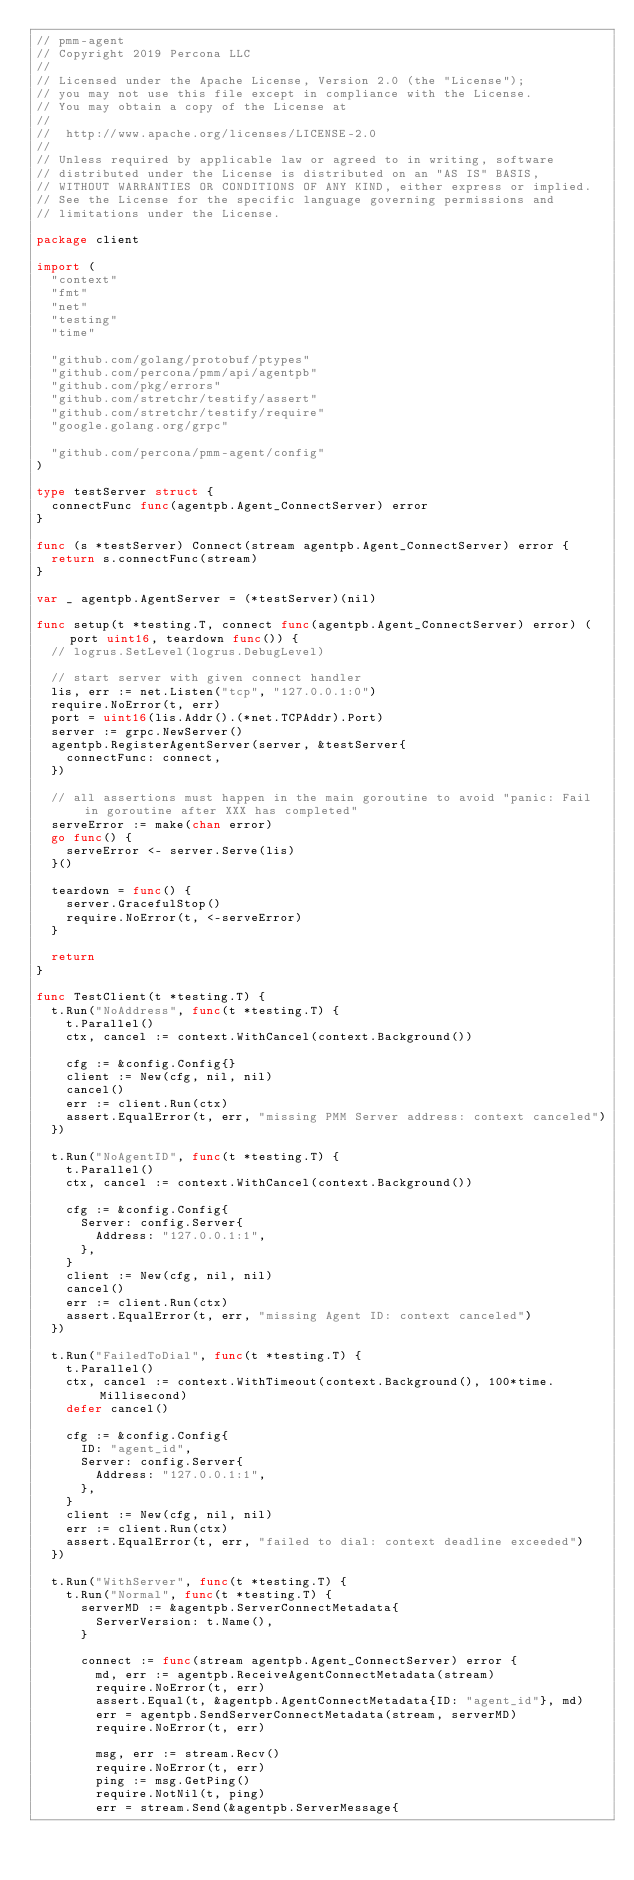Convert code to text. <code><loc_0><loc_0><loc_500><loc_500><_Go_>// pmm-agent
// Copyright 2019 Percona LLC
//
// Licensed under the Apache License, Version 2.0 (the "License");
// you may not use this file except in compliance with the License.
// You may obtain a copy of the License at
//
//  http://www.apache.org/licenses/LICENSE-2.0
//
// Unless required by applicable law or agreed to in writing, software
// distributed under the License is distributed on an "AS IS" BASIS,
// WITHOUT WARRANTIES OR CONDITIONS OF ANY KIND, either express or implied.
// See the License for the specific language governing permissions and
// limitations under the License.

package client

import (
	"context"
	"fmt"
	"net"
	"testing"
	"time"

	"github.com/golang/protobuf/ptypes"
	"github.com/percona/pmm/api/agentpb"
	"github.com/pkg/errors"
	"github.com/stretchr/testify/assert"
	"github.com/stretchr/testify/require"
	"google.golang.org/grpc"

	"github.com/percona/pmm-agent/config"
)

type testServer struct {
	connectFunc func(agentpb.Agent_ConnectServer) error
}

func (s *testServer) Connect(stream agentpb.Agent_ConnectServer) error {
	return s.connectFunc(stream)
}

var _ agentpb.AgentServer = (*testServer)(nil)

func setup(t *testing.T, connect func(agentpb.Agent_ConnectServer) error) (port uint16, teardown func()) {
	// logrus.SetLevel(logrus.DebugLevel)

	// start server with given connect handler
	lis, err := net.Listen("tcp", "127.0.0.1:0")
	require.NoError(t, err)
	port = uint16(lis.Addr().(*net.TCPAddr).Port)
	server := grpc.NewServer()
	agentpb.RegisterAgentServer(server, &testServer{
		connectFunc: connect,
	})

	// all assertions must happen in the main goroutine to avoid "panic: Fail in goroutine after XXX has completed"
	serveError := make(chan error)
	go func() {
		serveError <- server.Serve(lis)
	}()

	teardown = func() {
		server.GracefulStop()
		require.NoError(t, <-serveError)
	}

	return
}

func TestClient(t *testing.T) {
	t.Run("NoAddress", func(t *testing.T) {
		t.Parallel()
		ctx, cancel := context.WithCancel(context.Background())

		cfg := &config.Config{}
		client := New(cfg, nil, nil)
		cancel()
		err := client.Run(ctx)
		assert.EqualError(t, err, "missing PMM Server address: context canceled")
	})

	t.Run("NoAgentID", func(t *testing.T) {
		t.Parallel()
		ctx, cancel := context.WithCancel(context.Background())

		cfg := &config.Config{
			Server: config.Server{
				Address: "127.0.0.1:1",
			},
		}
		client := New(cfg, nil, nil)
		cancel()
		err := client.Run(ctx)
		assert.EqualError(t, err, "missing Agent ID: context canceled")
	})

	t.Run("FailedToDial", func(t *testing.T) {
		t.Parallel()
		ctx, cancel := context.WithTimeout(context.Background(), 100*time.Millisecond)
		defer cancel()

		cfg := &config.Config{
			ID: "agent_id",
			Server: config.Server{
				Address: "127.0.0.1:1",
			},
		}
		client := New(cfg, nil, nil)
		err := client.Run(ctx)
		assert.EqualError(t, err, "failed to dial: context deadline exceeded")
	})

	t.Run("WithServer", func(t *testing.T) {
		t.Run("Normal", func(t *testing.T) {
			serverMD := &agentpb.ServerConnectMetadata{
				ServerVersion: t.Name(),
			}

			connect := func(stream agentpb.Agent_ConnectServer) error {
				md, err := agentpb.ReceiveAgentConnectMetadata(stream)
				require.NoError(t, err)
				assert.Equal(t, &agentpb.AgentConnectMetadata{ID: "agent_id"}, md)
				err = agentpb.SendServerConnectMetadata(stream, serverMD)
				require.NoError(t, err)

				msg, err := stream.Recv()
				require.NoError(t, err)
				ping := msg.GetPing()
				require.NotNil(t, ping)
				err = stream.Send(&agentpb.ServerMessage{</code> 